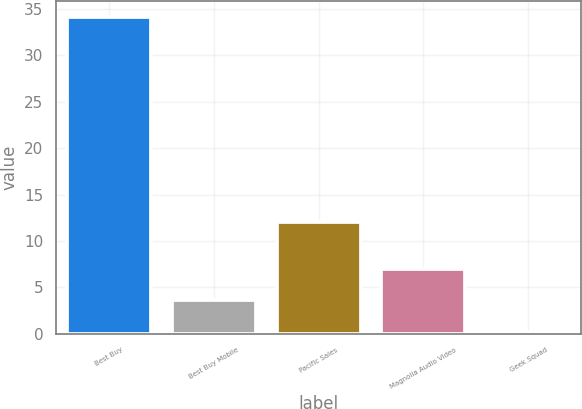Convert chart to OTSL. <chart><loc_0><loc_0><loc_500><loc_500><bar_chart><fcel>Best Buy<fcel>Best Buy Mobile<fcel>Pacific Sales<fcel>Magnolia Audio Video<fcel>Geek Squad<nl><fcel>34.2<fcel>3.6<fcel>12<fcel>7<fcel>0.2<nl></chart> 